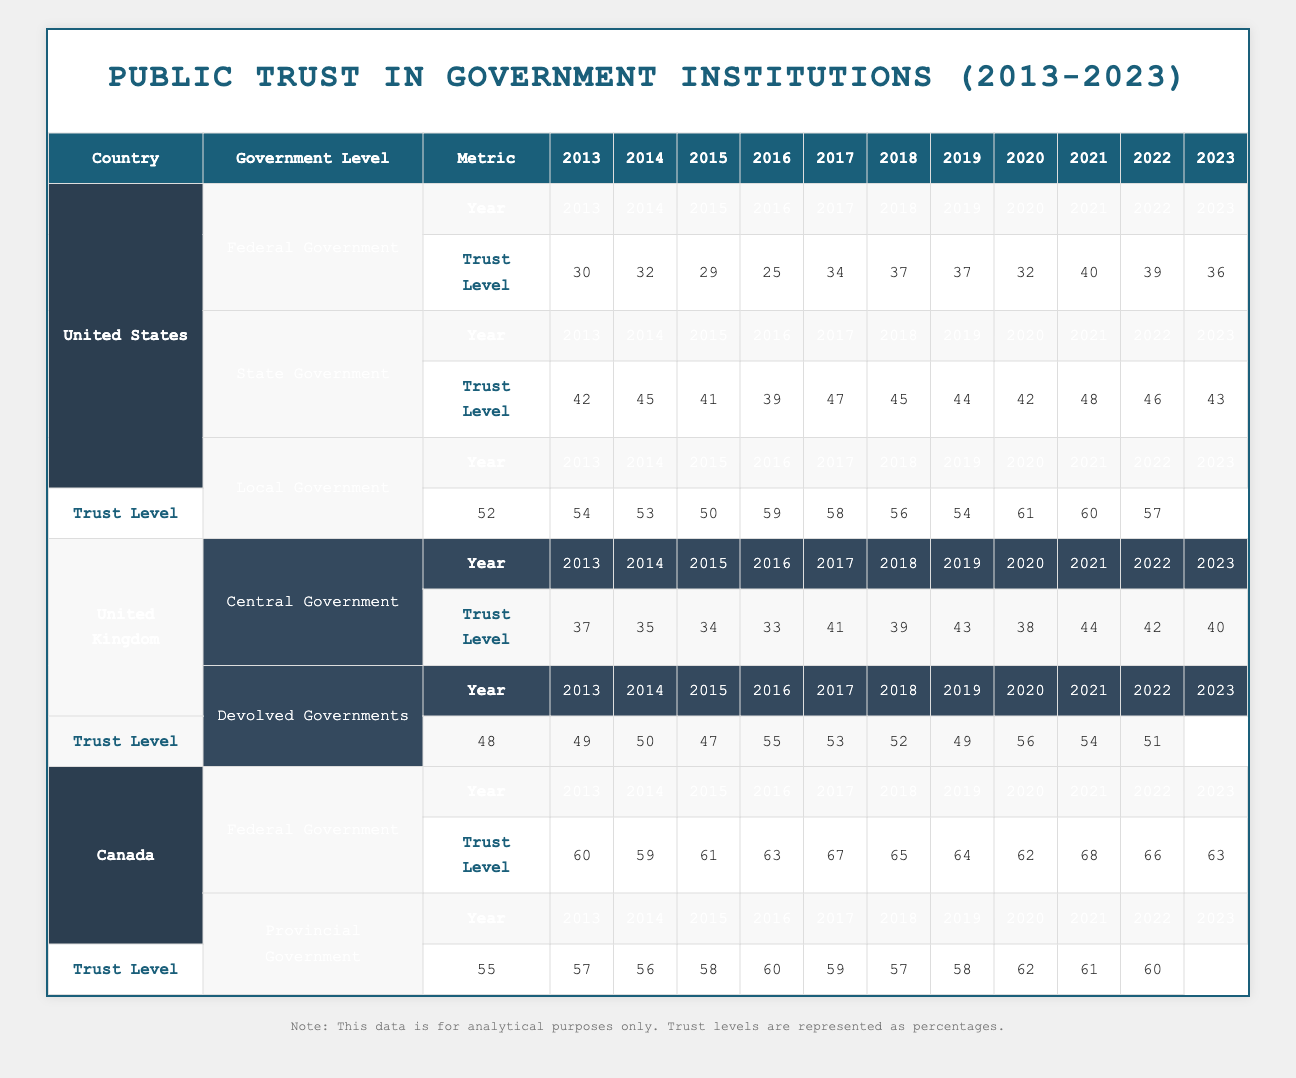What was the trust level in the Federal Government of the United States in 2015? In the table, I can find the row for the United States under Federal Government, and then look for the column corresponding to the year 2015. The trust level is listed as 29.
Answer: 29 What is the difference in trust levels for the Local Government in the United States between 2013 and 2023? For the Local Government in the United States, the trust level in 2013 is 52 and in 2023 it is 57. To find the difference, I subtract 52 from 57, which gives 5.
Answer: 5 Did the trust level for Central Government in the United Kingdom decrease from 2014 to 2016? Looking at the Central Government trust levels, in 2014 it was 35 and in 2016 it was 33. Since 33 is less than 35, we can conclude that it did decrease during this time.
Answer: Yes Which government level in Canada had the highest trust level in 2017? In 2017, I can see the trust levels listed for both Federal and Provincial Governments in Canada. The Federal Government had a trust level of 67, while the Provincial Government had 60. Since 67 is greater than 60, the Federal Government had the highest trust level in 2017.
Answer: Federal Government What is the average trust level for State Government in the United States from 2013 to 2023? To calculate the average, I will sum the trust levels from each year (42 + 45 + 41 + 39 + 47 + 45 + 44 + 42 + 48 + 46 + 43) which equals  487. There are 11 data points, so I divide 487 by 11, resulting in an average of approximately 44.27.
Answer: 44.27 Which country had the lowest trust level for Local Government in 2016? I can check the Local Government trust levels for each country in 2016. The United States had 50, the United Kingdom did not have data in that category, and Canada did not have data in that category as well. Since United States has the only value available for that year, it had the lowest trust level.
Answer: United States 